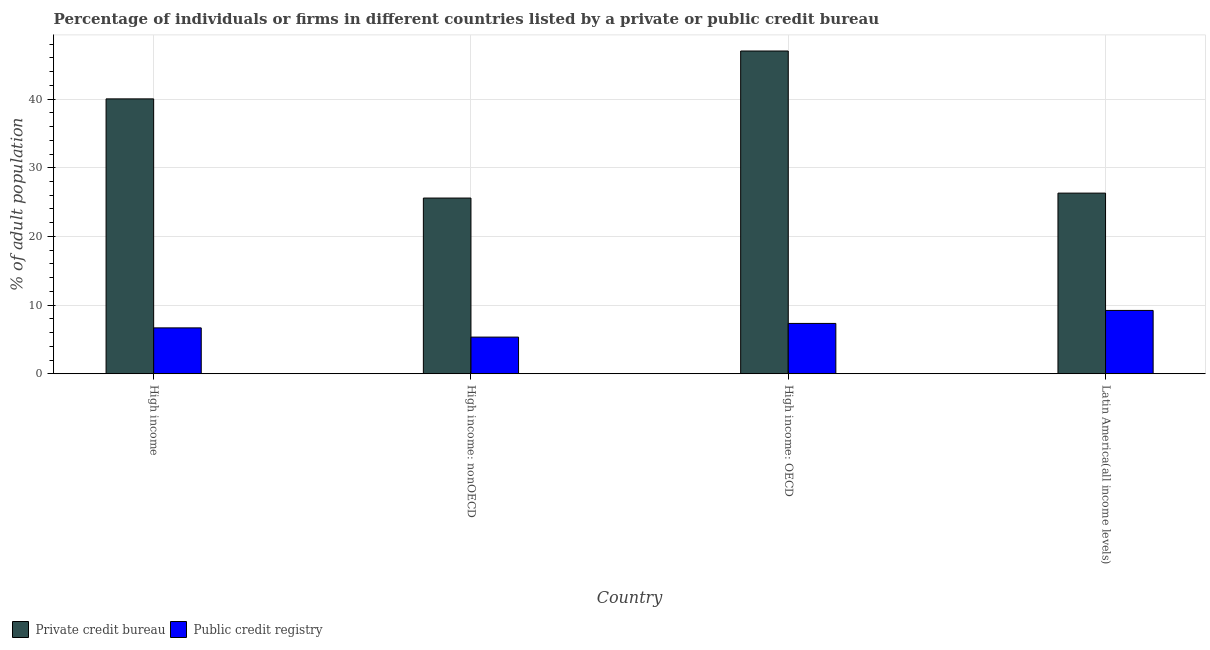How many different coloured bars are there?
Ensure brevity in your answer.  2. How many groups of bars are there?
Offer a terse response. 4. Are the number of bars per tick equal to the number of legend labels?
Your answer should be very brief. Yes. How many bars are there on the 4th tick from the left?
Ensure brevity in your answer.  2. What is the label of the 2nd group of bars from the left?
Provide a succinct answer. High income: nonOECD. What is the percentage of firms listed by private credit bureau in Latin America(all income levels)?
Make the answer very short. 26.3. Across all countries, what is the maximum percentage of firms listed by public credit bureau?
Offer a terse response. 9.22. Across all countries, what is the minimum percentage of firms listed by public credit bureau?
Your response must be concise. 5.34. In which country was the percentage of firms listed by public credit bureau maximum?
Offer a terse response. Latin America(all income levels). In which country was the percentage of firms listed by private credit bureau minimum?
Provide a succinct answer. High income: nonOECD. What is the total percentage of firms listed by public credit bureau in the graph?
Your response must be concise. 28.56. What is the difference between the percentage of firms listed by private credit bureau in High income: OECD and that in High income: nonOECD?
Provide a short and direct response. 21.41. What is the difference between the percentage of firms listed by public credit bureau in Latin America(all income levels) and the percentage of firms listed by private credit bureau in High income: nonOECD?
Keep it short and to the point. -16.37. What is the average percentage of firms listed by private credit bureau per country?
Keep it short and to the point. 34.73. What is the difference between the percentage of firms listed by private credit bureau and percentage of firms listed by public credit bureau in High income?
Give a very brief answer. 33.35. In how many countries, is the percentage of firms listed by public credit bureau greater than 6 %?
Provide a short and direct response. 3. What is the ratio of the percentage of firms listed by public credit bureau in High income: OECD to that in High income: nonOECD?
Your response must be concise. 1.37. Is the difference between the percentage of firms listed by public credit bureau in High income: OECD and Latin America(all income levels) greater than the difference between the percentage of firms listed by private credit bureau in High income: OECD and Latin America(all income levels)?
Keep it short and to the point. No. What is the difference between the highest and the second highest percentage of firms listed by private credit bureau?
Your response must be concise. 6.97. What is the difference between the highest and the lowest percentage of firms listed by private credit bureau?
Give a very brief answer. 21.41. In how many countries, is the percentage of firms listed by private credit bureau greater than the average percentage of firms listed by private credit bureau taken over all countries?
Your answer should be compact. 2. What does the 1st bar from the left in High income represents?
Your answer should be compact. Private credit bureau. What does the 2nd bar from the right in High income: nonOECD represents?
Offer a very short reply. Private credit bureau. Where does the legend appear in the graph?
Offer a very short reply. Bottom left. How many legend labels are there?
Your response must be concise. 2. What is the title of the graph?
Offer a terse response. Percentage of individuals or firms in different countries listed by a private or public credit bureau. Does "Largest city" appear as one of the legend labels in the graph?
Provide a short and direct response. No. What is the label or title of the Y-axis?
Make the answer very short. % of adult population. What is the % of adult population of Private credit bureau in High income?
Make the answer very short. 40.03. What is the % of adult population in Public credit registry in High income?
Your answer should be compact. 6.68. What is the % of adult population of Private credit bureau in High income: nonOECD?
Make the answer very short. 25.59. What is the % of adult population of Public credit registry in High income: nonOECD?
Offer a terse response. 5.34. What is the % of adult population in Private credit bureau in High income: OECD?
Make the answer very short. 47. What is the % of adult population of Public credit registry in High income: OECD?
Make the answer very short. 7.33. What is the % of adult population in Private credit bureau in Latin America(all income levels)?
Your response must be concise. 26.3. What is the % of adult population in Public credit registry in Latin America(all income levels)?
Your answer should be very brief. 9.22. Across all countries, what is the maximum % of adult population of Public credit registry?
Your answer should be very brief. 9.22. Across all countries, what is the minimum % of adult population of Private credit bureau?
Ensure brevity in your answer.  25.59. Across all countries, what is the minimum % of adult population in Public credit registry?
Provide a short and direct response. 5.34. What is the total % of adult population in Private credit bureau in the graph?
Offer a very short reply. 138.92. What is the total % of adult population of Public credit registry in the graph?
Offer a terse response. 28.56. What is the difference between the % of adult population in Private credit bureau in High income and that in High income: nonOECD?
Your response must be concise. 14.44. What is the difference between the % of adult population of Public credit registry in High income and that in High income: nonOECD?
Ensure brevity in your answer.  1.34. What is the difference between the % of adult population in Private credit bureau in High income and that in High income: OECD?
Your answer should be compact. -6.97. What is the difference between the % of adult population of Public credit registry in High income and that in High income: OECD?
Keep it short and to the point. -0.65. What is the difference between the % of adult population in Private credit bureau in High income and that in Latin America(all income levels)?
Your response must be concise. 13.72. What is the difference between the % of adult population of Public credit registry in High income and that in Latin America(all income levels)?
Give a very brief answer. -2.54. What is the difference between the % of adult population in Private credit bureau in High income: nonOECD and that in High income: OECD?
Your answer should be compact. -21.41. What is the difference between the % of adult population in Public credit registry in High income: nonOECD and that in High income: OECD?
Your response must be concise. -1.99. What is the difference between the % of adult population in Private credit bureau in High income: nonOECD and that in Latin America(all income levels)?
Offer a very short reply. -0.72. What is the difference between the % of adult population of Public credit registry in High income: nonOECD and that in Latin America(all income levels)?
Your answer should be very brief. -3.88. What is the difference between the % of adult population of Private credit bureau in High income: OECD and that in Latin America(all income levels)?
Make the answer very short. 20.7. What is the difference between the % of adult population in Public credit registry in High income: OECD and that in Latin America(all income levels)?
Your answer should be very brief. -1.89. What is the difference between the % of adult population in Private credit bureau in High income and the % of adult population in Public credit registry in High income: nonOECD?
Make the answer very short. 34.69. What is the difference between the % of adult population in Private credit bureau in High income and the % of adult population in Public credit registry in High income: OECD?
Offer a terse response. 32.7. What is the difference between the % of adult population in Private credit bureau in High income and the % of adult population in Public credit registry in Latin America(all income levels)?
Make the answer very short. 30.81. What is the difference between the % of adult population in Private credit bureau in High income: nonOECD and the % of adult population in Public credit registry in High income: OECD?
Offer a terse response. 18.26. What is the difference between the % of adult population in Private credit bureau in High income: nonOECD and the % of adult population in Public credit registry in Latin America(all income levels)?
Keep it short and to the point. 16.37. What is the difference between the % of adult population of Private credit bureau in High income: OECD and the % of adult population of Public credit registry in Latin America(all income levels)?
Keep it short and to the point. 37.78. What is the average % of adult population in Private credit bureau per country?
Make the answer very short. 34.73. What is the average % of adult population of Public credit registry per country?
Provide a succinct answer. 7.14. What is the difference between the % of adult population in Private credit bureau and % of adult population in Public credit registry in High income?
Your response must be concise. 33.35. What is the difference between the % of adult population of Private credit bureau and % of adult population of Public credit registry in High income: nonOECD?
Offer a very short reply. 20.25. What is the difference between the % of adult population of Private credit bureau and % of adult population of Public credit registry in High income: OECD?
Make the answer very short. 39.67. What is the difference between the % of adult population in Private credit bureau and % of adult population in Public credit registry in Latin America(all income levels)?
Offer a very short reply. 17.09. What is the ratio of the % of adult population in Private credit bureau in High income to that in High income: nonOECD?
Keep it short and to the point. 1.56. What is the ratio of the % of adult population of Public credit registry in High income to that in High income: nonOECD?
Offer a terse response. 1.25. What is the ratio of the % of adult population in Private credit bureau in High income to that in High income: OECD?
Your answer should be very brief. 0.85. What is the ratio of the % of adult population in Public credit registry in High income to that in High income: OECD?
Provide a short and direct response. 0.91. What is the ratio of the % of adult population in Private credit bureau in High income to that in Latin America(all income levels)?
Keep it short and to the point. 1.52. What is the ratio of the % of adult population in Public credit registry in High income to that in Latin America(all income levels)?
Make the answer very short. 0.72. What is the ratio of the % of adult population in Private credit bureau in High income: nonOECD to that in High income: OECD?
Ensure brevity in your answer.  0.54. What is the ratio of the % of adult population in Public credit registry in High income: nonOECD to that in High income: OECD?
Offer a very short reply. 0.73. What is the ratio of the % of adult population in Private credit bureau in High income: nonOECD to that in Latin America(all income levels)?
Make the answer very short. 0.97. What is the ratio of the % of adult population in Public credit registry in High income: nonOECD to that in Latin America(all income levels)?
Keep it short and to the point. 0.58. What is the ratio of the % of adult population of Private credit bureau in High income: OECD to that in Latin America(all income levels)?
Your answer should be compact. 1.79. What is the ratio of the % of adult population in Public credit registry in High income: OECD to that in Latin America(all income levels)?
Provide a succinct answer. 0.79. What is the difference between the highest and the second highest % of adult population of Private credit bureau?
Your answer should be compact. 6.97. What is the difference between the highest and the second highest % of adult population of Public credit registry?
Keep it short and to the point. 1.89. What is the difference between the highest and the lowest % of adult population of Private credit bureau?
Your answer should be compact. 21.41. What is the difference between the highest and the lowest % of adult population in Public credit registry?
Your answer should be very brief. 3.88. 